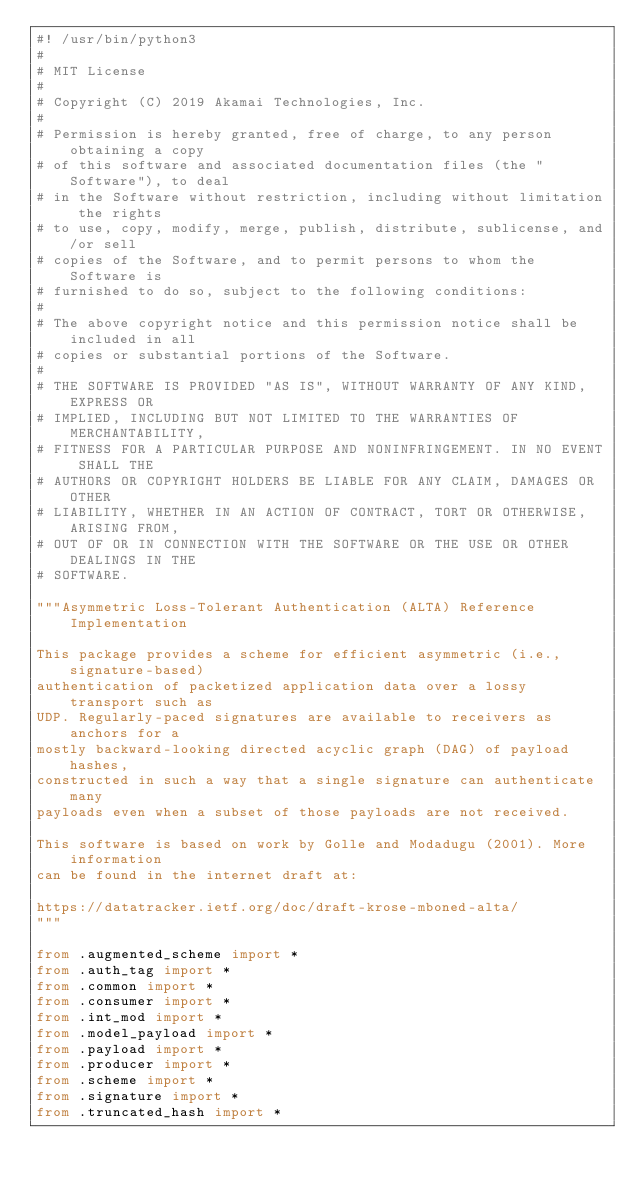<code> <loc_0><loc_0><loc_500><loc_500><_Python_>#! /usr/bin/python3
#
# MIT License
#
# Copyright (C) 2019 Akamai Technologies, Inc.
#
# Permission is hereby granted, free of charge, to any person obtaining a copy
# of this software and associated documentation files (the "Software"), to deal
# in the Software without restriction, including without limitation the rights
# to use, copy, modify, merge, publish, distribute, sublicense, and/or sell
# copies of the Software, and to permit persons to whom the Software is
# furnished to do so, subject to the following conditions:
#
# The above copyright notice and this permission notice shall be included in all
# copies or substantial portions of the Software.
#
# THE SOFTWARE IS PROVIDED "AS IS", WITHOUT WARRANTY OF ANY KIND, EXPRESS OR
# IMPLIED, INCLUDING BUT NOT LIMITED TO THE WARRANTIES OF MERCHANTABILITY,
# FITNESS FOR A PARTICULAR PURPOSE AND NONINFRINGEMENT. IN NO EVENT SHALL THE
# AUTHORS OR COPYRIGHT HOLDERS BE LIABLE FOR ANY CLAIM, DAMAGES OR OTHER
# LIABILITY, WHETHER IN AN ACTION OF CONTRACT, TORT OR OTHERWISE, ARISING FROM,
# OUT OF OR IN CONNECTION WITH THE SOFTWARE OR THE USE OR OTHER DEALINGS IN THE
# SOFTWARE.

"""Asymmetric Loss-Tolerant Authentication (ALTA) Reference Implementation

This package provides a scheme for efficient asymmetric (i.e., signature-based)
authentication of packetized application data over a lossy transport such as
UDP. Regularly-paced signatures are available to receivers as anchors for a
mostly backward-looking directed acyclic graph (DAG) of payload hashes,
constructed in such a way that a single signature can authenticate many
payloads even when a subset of those payloads are not received.

This software is based on work by Golle and Modadugu (2001). More information
can be found in the internet draft at:

https://datatracker.ietf.org/doc/draft-krose-mboned-alta/
"""

from .augmented_scheme import *
from .auth_tag import *
from .common import *
from .consumer import *
from .int_mod import *
from .model_payload import *
from .payload import *
from .producer import *
from .scheme import *
from .signature import *
from .truncated_hash import *
</code> 